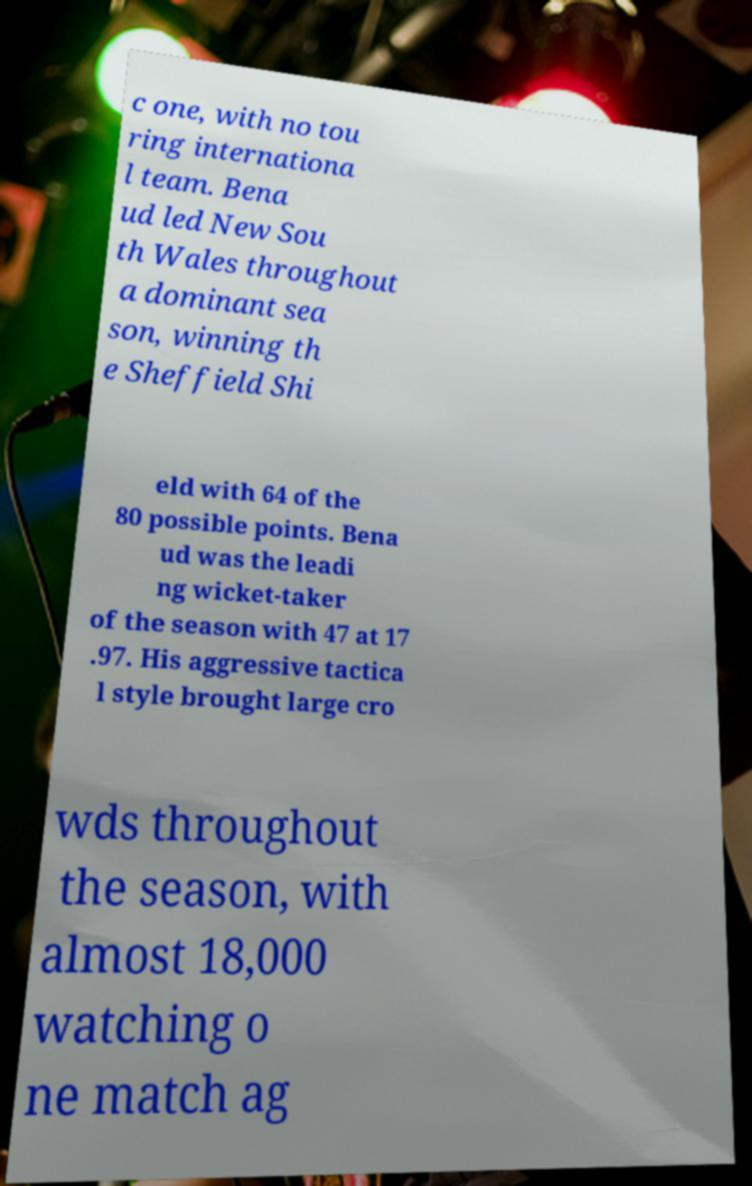Could you assist in decoding the text presented in this image and type it out clearly? c one, with no tou ring internationa l team. Bena ud led New Sou th Wales throughout a dominant sea son, winning th e Sheffield Shi eld with 64 of the 80 possible points. Bena ud was the leadi ng wicket-taker of the season with 47 at 17 .97. His aggressive tactica l style brought large cro wds throughout the season, with almost 18,000 watching o ne match ag 